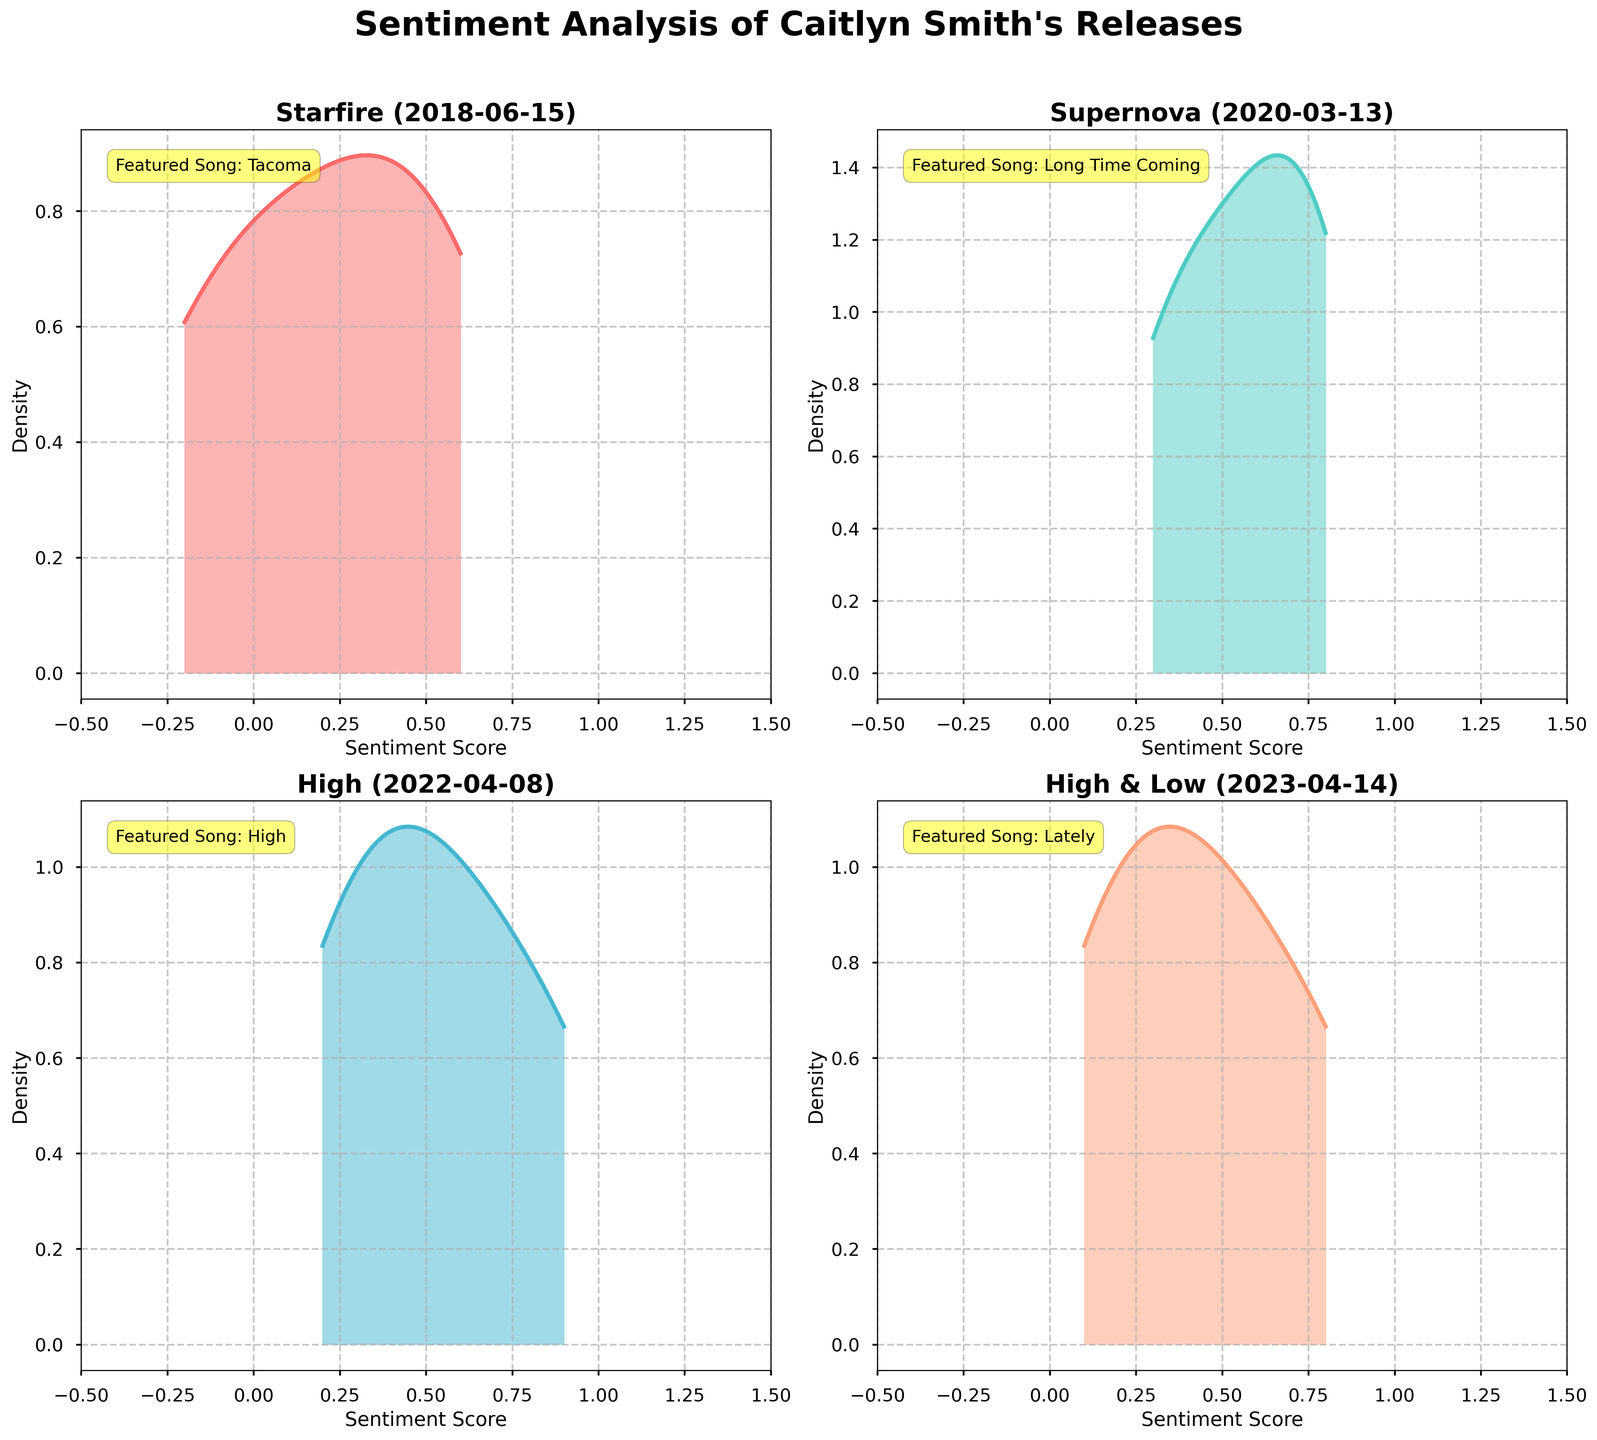What's the title of the entire plot? The title can be found at the top of the figure in bold style, stating the main subject of the plot.
Answer: Sentiment Analysis of Caitlyn Smith's Releases What is the x-axis label used in each subplot? The x-axis label is mentioned below the x-axis line in each subplot and indicates the dimension being measured.
Answer: Sentiment Score Which album has the densest peak nearest to the sentiment score of 0.8? By observing the density curves, the densest peak near 0.8 can be identified.
Answer: Supernova What is the featured song for the album "High & Low"? You can find this information annotated as text within the subplot related to the "High & Low" album.
Answer: Lately How many subplots are present in the main figure? The number of smaller plots distributed within the main figure can be counted.
Answer: 4 Which album has the lowest sentiment score range plotted on the density plots? By inspecting the minima and maxima on the x-axis of each subplot, we can determine the range for each album.
Answer: Starfire Which subplot has the distribution with the highest positive sentiment score? Observing the furthest point on the right along the density curve within the subplots will give this information.
Answer: High Compare the average sentiment scores of "Starfire" and "High", which album has a higher average sentiment score? Estimate the average sentiment scores based on the shape and peak of the distribution and compare them.
Answer: High What are the colors used for the density plot of the album "Starfire"? The fill color and curve color for the "Starfire" subplot can be identified by observing the plot.
Answer: Red Among "Supernova" and "High & Low," which album shows a wider distribution of sentiment scores? By comparing the spread of the density plots on the x-axis for the two albums, one can determine which has a wider range.
Answer: High & Low 